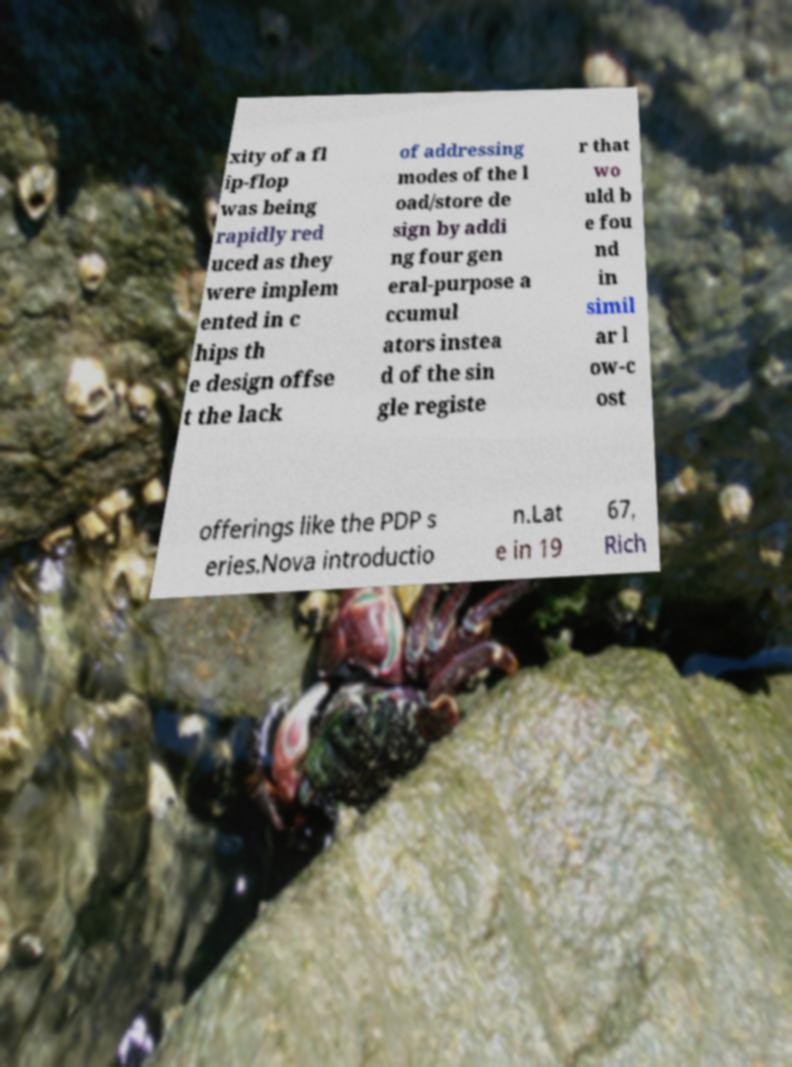I need the written content from this picture converted into text. Can you do that? xity of a fl ip-flop was being rapidly red uced as they were implem ented in c hips th e design offse t the lack of addressing modes of the l oad/store de sign by addi ng four gen eral-purpose a ccumul ators instea d of the sin gle registe r that wo uld b e fou nd in simil ar l ow-c ost offerings like the PDP s eries.Nova introductio n.Lat e in 19 67, Rich 